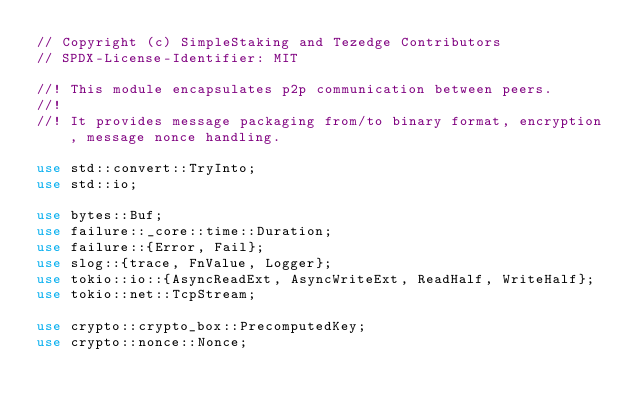Convert code to text. <code><loc_0><loc_0><loc_500><loc_500><_Rust_>// Copyright (c) SimpleStaking and Tezedge Contributors
// SPDX-License-Identifier: MIT

//! This module encapsulates p2p communication between peers.
//!
//! It provides message packaging from/to binary format, encryption, message nonce handling.

use std::convert::TryInto;
use std::io;

use bytes::Buf;
use failure::_core::time::Duration;
use failure::{Error, Fail};
use slog::{trace, FnValue, Logger};
use tokio::io::{AsyncReadExt, AsyncWriteExt, ReadHalf, WriteHalf};
use tokio::net::TcpStream;

use crypto::crypto_box::PrecomputedKey;
use crypto::nonce::Nonce;</code> 